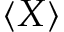Convert formula to latex. <formula><loc_0><loc_0><loc_500><loc_500>\langle X \rangle</formula> 